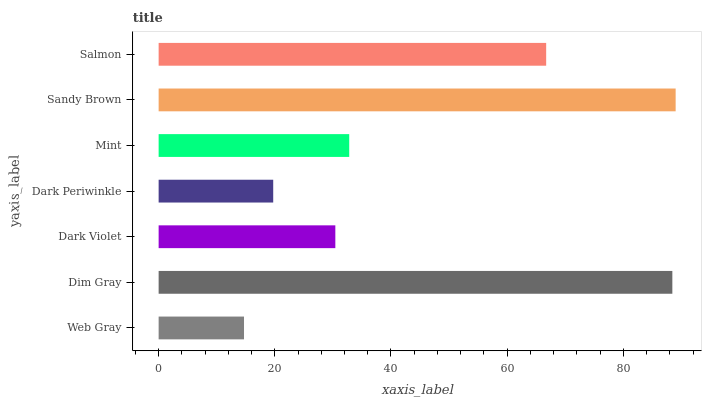Is Web Gray the minimum?
Answer yes or no. Yes. Is Sandy Brown the maximum?
Answer yes or no. Yes. Is Dim Gray the minimum?
Answer yes or no. No. Is Dim Gray the maximum?
Answer yes or no. No. Is Dim Gray greater than Web Gray?
Answer yes or no. Yes. Is Web Gray less than Dim Gray?
Answer yes or no. Yes. Is Web Gray greater than Dim Gray?
Answer yes or no. No. Is Dim Gray less than Web Gray?
Answer yes or no. No. Is Mint the high median?
Answer yes or no. Yes. Is Mint the low median?
Answer yes or no. Yes. Is Web Gray the high median?
Answer yes or no. No. Is Dark Periwinkle the low median?
Answer yes or no. No. 